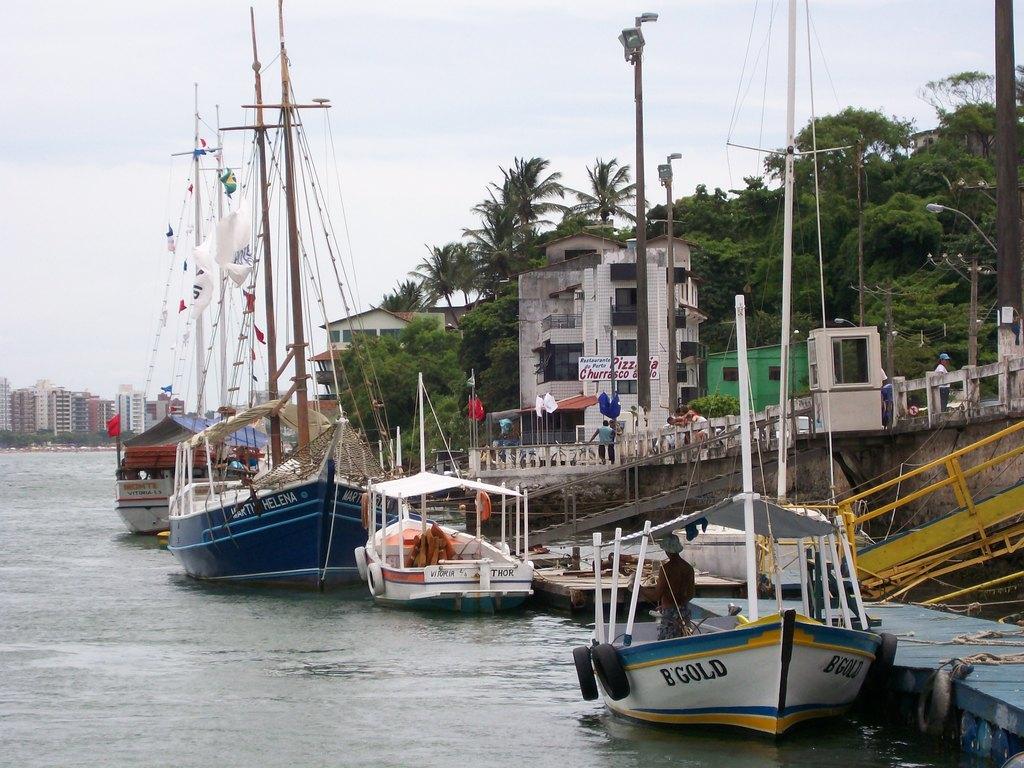How would you summarize this image in a sentence or two? In this image I can see few ship on the water. They are in different color. We can see buildings and windows. There is a fencing and few people around. We can see light-poles and trees. The sky is in blue and white color. We can see red color flag. 